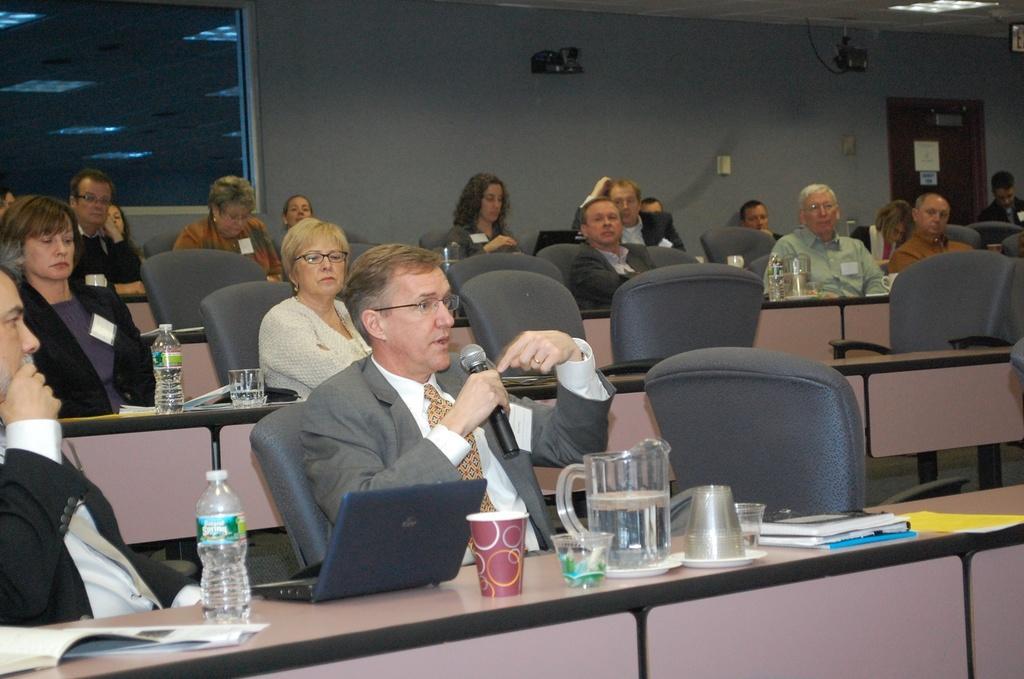Could you give a brief overview of what you see in this image? In this image i can see few people sitting on chairs in front of desk. On the desks i can see water bottles, glasses and few papers. In the background i can see a wall and a door. 